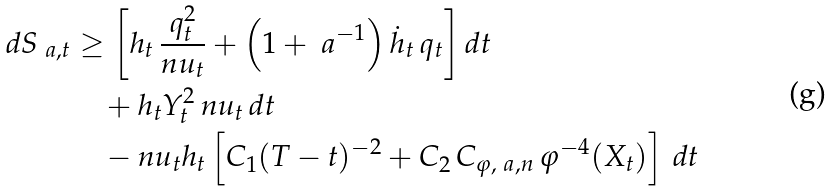Convert formula to latex. <formula><loc_0><loc_0><loc_500><loc_500>d S _ { \ a , t } & \geq \left [ h _ { t } \, \frac { q _ { t } ^ { 2 } } { n u _ { t } } + \left ( 1 + \ a ^ { - 1 } \right ) \dot { h } _ { t } \, q _ { t } \right ] d t \\ & \quad + h _ { t } Y _ { t } ^ { 2 } \, n u _ { t } \, d t \\ & \quad - n u _ { t } h _ { t } \left [ C _ { 1 } ( T - t ) ^ { - 2 } + C _ { 2 } \, C _ { \varphi , \ a , n } \, \varphi ^ { - 4 } ( X _ { t } ) \right ] \, d t</formula> 